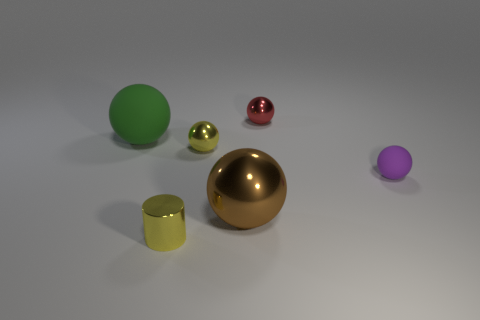Subtract all tiny red spheres. How many spheres are left? 4 Subtract all purple balls. How many balls are left? 4 Add 4 tiny yellow objects. How many objects exist? 10 Subtract all tiny yellow cylinders. Subtract all yellow spheres. How many objects are left? 4 Add 5 small yellow objects. How many small yellow objects are left? 7 Add 2 blue balls. How many blue balls exist? 2 Subtract 0 cyan cubes. How many objects are left? 6 Subtract all cylinders. How many objects are left? 5 Subtract all cyan balls. Subtract all gray blocks. How many balls are left? 5 